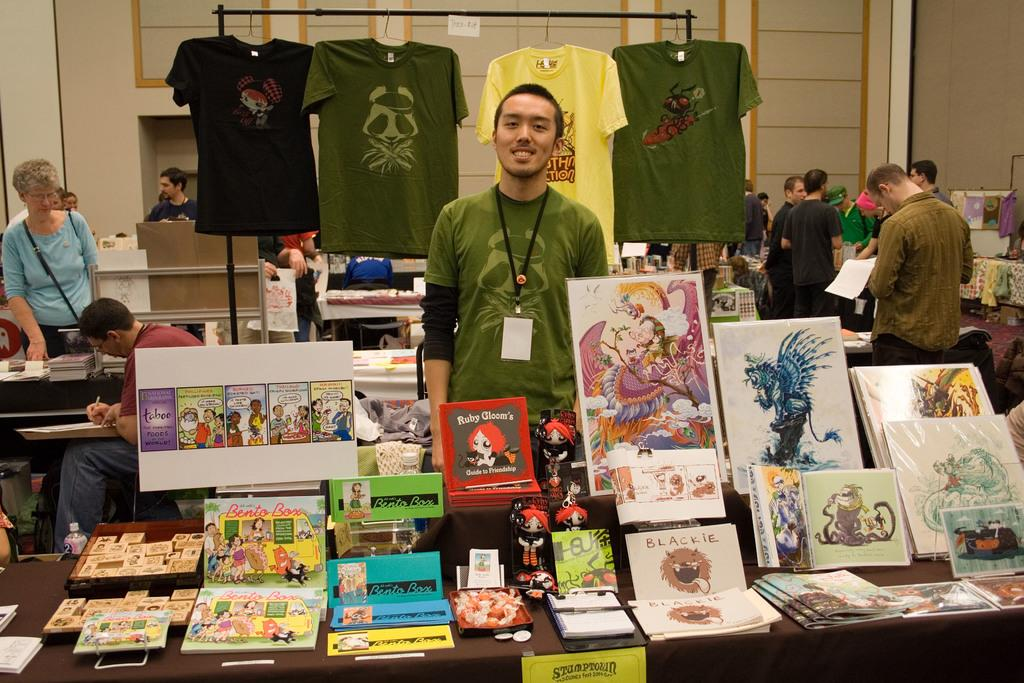<image>
Write a terse but informative summary of the picture. A man stands behind a table of artwork that is for sale with a yellow sign saying Stumptown taped to the front of the table. 